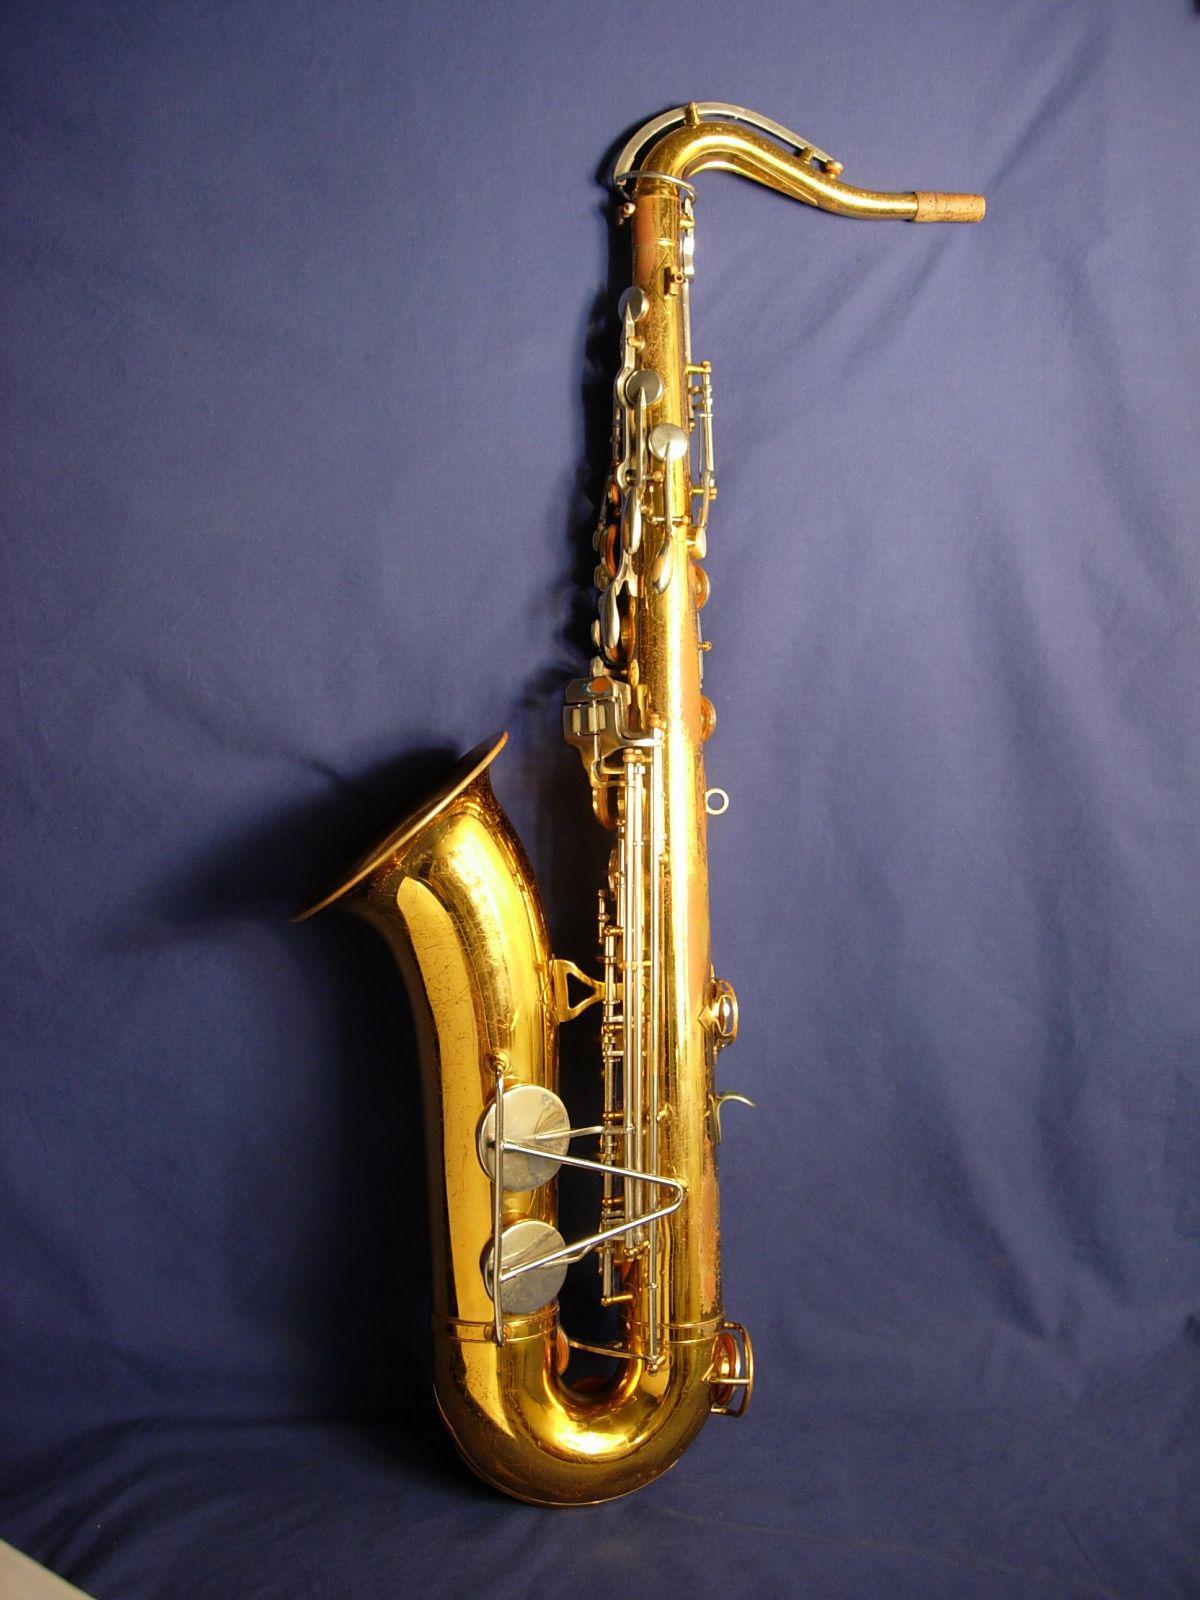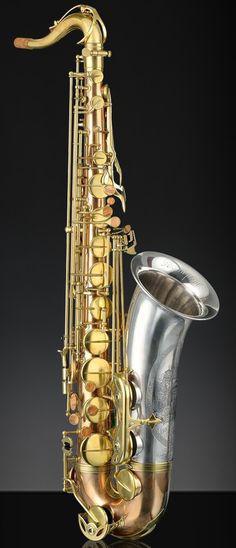The first image is the image on the left, the second image is the image on the right. For the images displayed, is the sentence "There is an image of a saxophone with its neck removed from the body of the instrument." factually correct? Answer yes or no. No. 